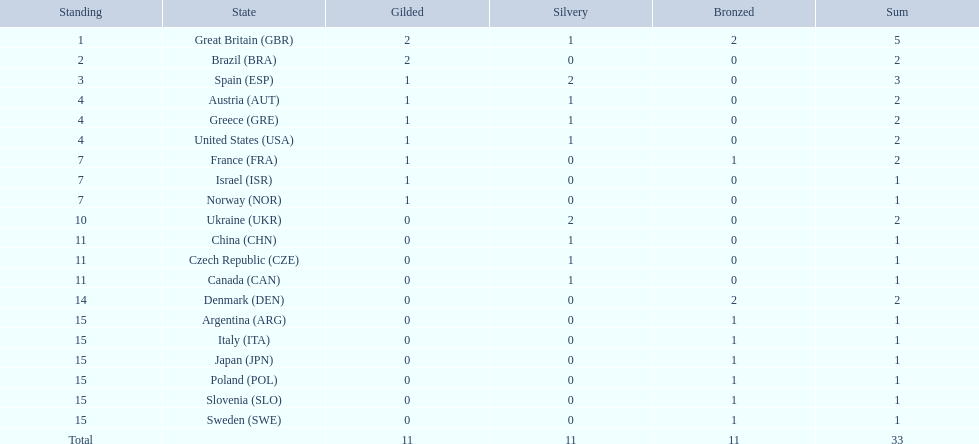What are all of the countries? Great Britain (GBR), Brazil (BRA), Spain (ESP), Austria (AUT), Greece (GRE), United States (USA), France (FRA), Israel (ISR), Norway (NOR), Ukraine (UKR), China (CHN), Czech Republic (CZE), Canada (CAN), Denmark (DEN), Argentina (ARG), Italy (ITA), Japan (JPN), Poland (POL), Slovenia (SLO), Sweden (SWE). Which ones earned a medal? Great Britain (GBR), Brazil (BRA), Spain (ESP), Austria (AUT), Greece (GRE), United States (USA), France (FRA), Israel (ISR), Norway (NOR), Ukraine (UKR), China (CHN), Czech Republic (CZE), Canada (CAN), Denmark (DEN), Argentina (ARG), Italy (ITA), Japan (JPN), Poland (POL), Slovenia (SLO), Sweden (SWE). Which countries earned at least 3 medals? Great Britain (GBR), Spain (ESP). Which country earned 3 medals? Spain (ESP). Parse the full table. {'header': ['Standing', 'State', 'Gilded', 'Silvery', 'Bronzed', 'Sum'], 'rows': [['1', 'Great Britain\xa0(GBR)', '2', '1', '2', '5'], ['2', 'Brazil\xa0(BRA)', '2', '0', '0', '2'], ['3', 'Spain\xa0(ESP)', '1', '2', '0', '3'], ['4', 'Austria\xa0(AUT)', '1', '1', '0', '2'], ['4', 'Greece\xa0(GRE)', '1', '1', '0', '2'], ['4', 'United States\xa0(USA)', '1', '1', '0', '2'], ['7', 'France\xa0(FRA)', '1', '0', '1', '2'], ['7', 'Israel\xa0(ISR)', '1', '0', '0', '1'], ['7', 'Norway\xa0(NOR)', '1', '0', '0', '1'], ['10', 'Ukraine\xa0(UKR)', '0', '2', '0', '2'], ['11', 'China\xa0(CHN)', '0', '1', '0', '1'], ['11', 'Czech Republic\xa0(CZE)', '0', '1', '0', '1'], ['11', 'Canada\xa0(CAN)', '0', '1', '0', '1'], ['14', 'Denmark\xa0(DEN)', '0', '0', '2', '2'], ['15', 'Argentina\xa0(ARG)', '0', '0', '1', '1'], ['15', 'Italy\xa0(ITA)', '0', '0', '1', '1'], ['15', 'Japan\xa0(JPN)', '0', '0', '1', '1'], ['15', 'Poland\xa0(POL)', '0', '0', '1', '1'], ['15', 'Slovenia\xa0(SLO)', '0', '0', '1', '1'], ['15', 'Sweden\xa0(SWE)', '0', '0', '1', '1'], ['Total', '', '11', '11', '11', '33']]} 